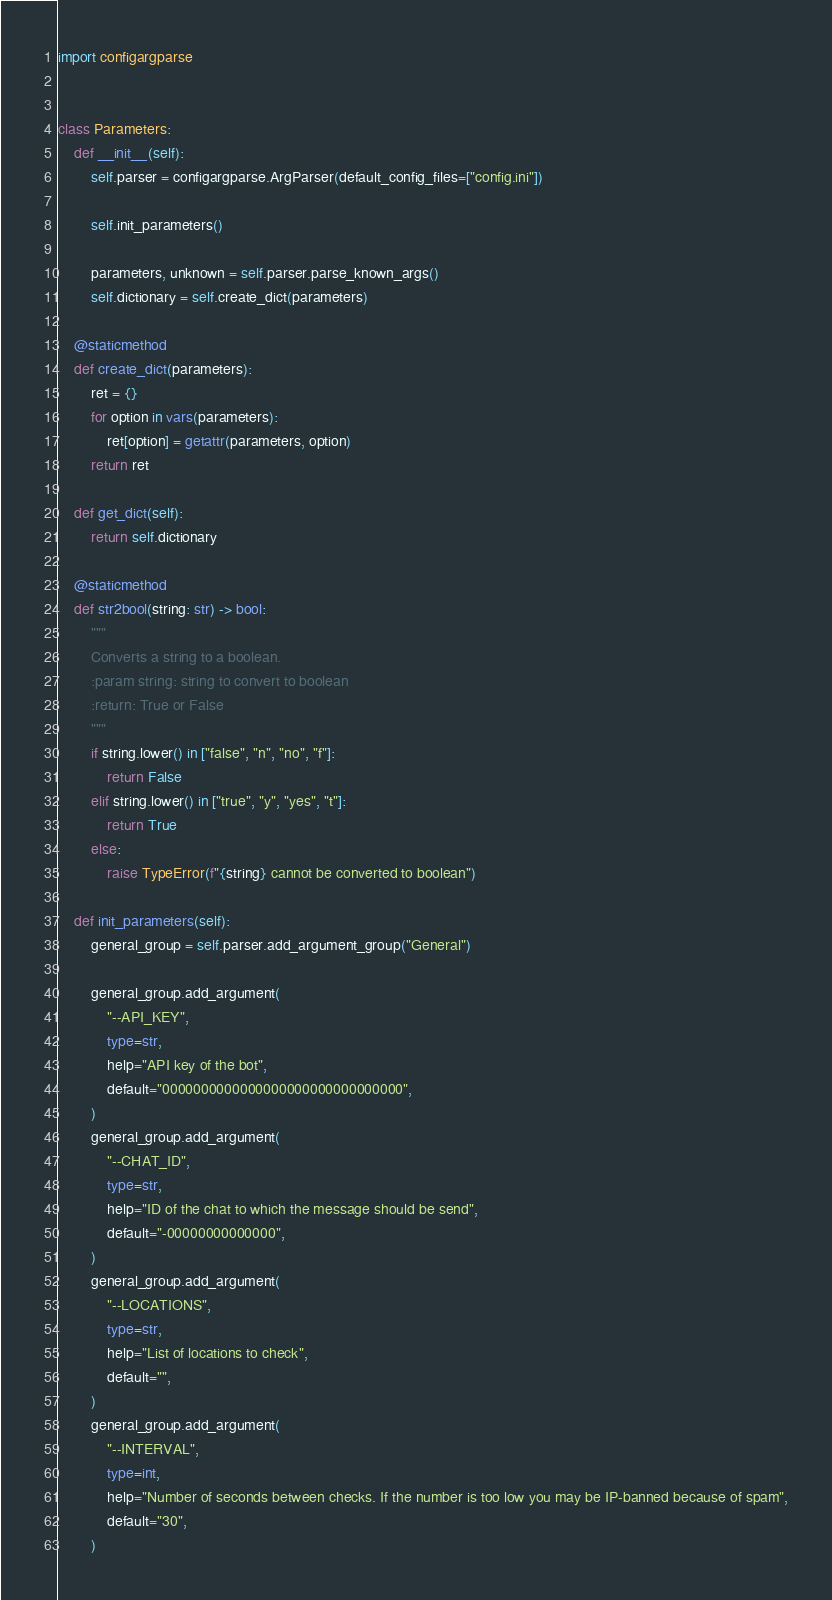Convert code to text. <code><loc_0><loc_0><loc_500><loc_500><_Python_>import configargparse


class Parameters:
    def __init__(self):
        self.parser = configargparse.ArgParser(default_config_files=["config.ini"])

        self.init_parameters()

        parameters, unknown = self.parser.parse_known_args()
        self.dictionary = self.create_dict(parameters)

    @staticmethod
    def create_dict(parameters):
        ret = {}
        for option in vars(parameters):
            ret[option] = getattr(parameters, option)
        return ret

    def get_dict(self):
        return self.dictionary

    @staticmethod
    def str2bool(string: str) -> bool:
        """
        Converts a string to a boolean.
        :param string: string to convert to boolean
        :return: True or False
        """
        if string.lower() in ["false", "n", "no", "f"]:
            return False
        elif string.lower() in ["true", "y", "yes", "t"]:
            return True
        else:
            raise TypeError(f"{string} cannot be converted to boolean")

    def init_parameters(self):
        general_group = self.parser.add_argument_group("General")

        general_group.add_argument(
            "--API_KEY",
            type=str,
            help="API key of the bot",
            default="0000000000000000000000000000000",
        )
        general_group.add_argument(
            "--CHAT_ID",
            type=str,
            help="ID of the chat to which the message should be send",
            default="-00000000000000", 
        )
        general_group.add_argument(
            "--LOCATIONS",
            type=str,
            help="List of locations to check",
            default="", 
        )
        general_group.add_argument(
            "--INTERVAL",
            type=int,
            help="Number of seconds between checks. If the number is too low you may be IP-banned because of spam",
            default="30",
        )</code> 